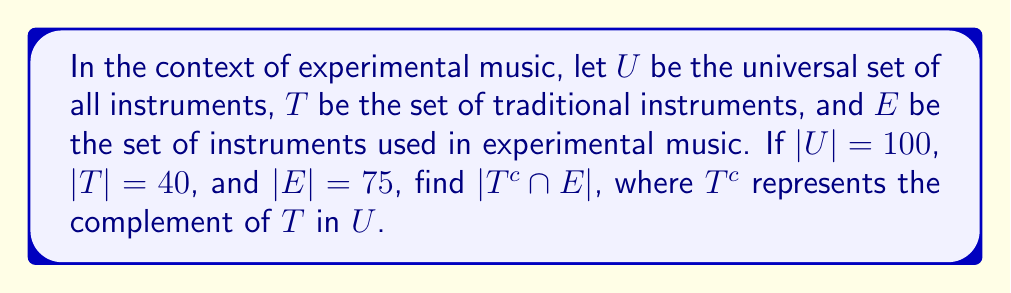What is the answer to this math problem? To solve this problem, we'll follow these steps:

1) First, let's understand what $T^c \cap E$ represents:
   - $T^c$ is the set of all non-traditional instruments
   - $E$ is the set of instruments used in experimental music
   - $T^c \cap E$ is the set of non-traditional instruments used in experimental music

2) We can use the following set theory formula:
   $$|T^c \cap E| = |E| - |T \cap E|$$

3) We know $|E| = 75$, but we don't know $|T \cap E|$. However, we can find it:
   $$|T \cap E| = |T| + |E| - |T \cup E|$$

4) We know $|T| = 40$ and $|E| = 75$, but we need to find $|T \cup E|$:
   $$|T \cup E| = |U| - |T^c \cap E^c|$$

5) We know $|U| = 100$, and we can find $|T^c \cap E^c|$ using:
   $$|T^c \cap E^c| = |U| - |T| - |E| + |T \cap E|$$

6) Substituting the known values:
   $$|T^c \cap E^c| = 100 - 40 - 75 + |T \cap E| = -15 + |T \cap E|$$

7) Now, going back to step 4:
   $$|T \cup E| = 100 - (-15 + |T \cap E|) = 115 - |T \cap E|$$

8) Substituting this into the equation from step 3:
   $$|T \cap E| = 40 + 75 - (115 - |T \cap E|)$$
   $$2|T \cap E| = 0$$
   $$|T \cap E| = 0$$

9) Finally, we can use the equation from step 2:
   $$|T^c \cap E| = |E| - |T \cap E| = 75 - 0 = 75$$
Answer: $|T^c \cap E| = 75$ 